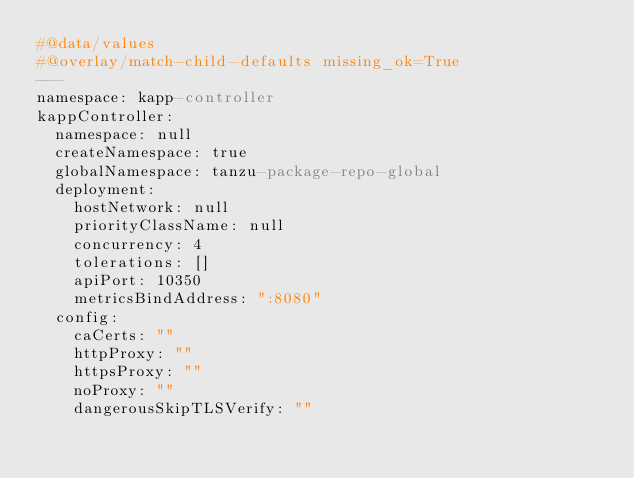<code> <loc_0><loc_0><loc_500><loc_500><_YAML_>#@data/values
#@overlay/match-child-defaults missing_ok=True
---
namespace: kapp-controller
kappController:
  namespace: null
  createNamespace: true
  globalNamespace: tanzu-package-repo-global
  deployment:
    hostNetwork: null
    priorityClassName: null
    concurrency: 4
    tolerations: []
    apiPort: 10350
    metricsBindAddress: ":8080"
  config:
    caCerts: ""
    httpProxy: ""
    httpsProxy: ""
    noProxy: ""
    dangerousSkipTLSVerify: ""
</code> 